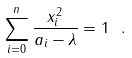Convert formula to latex. <formula><loc_0><loc_0><loc_500><loc_500>\sum _ { i = 0 } ^ { n } { \frac { x _ { i } ^ { 2 } } { a _ { i } - \lambda } } = 1 \ .</formula> 